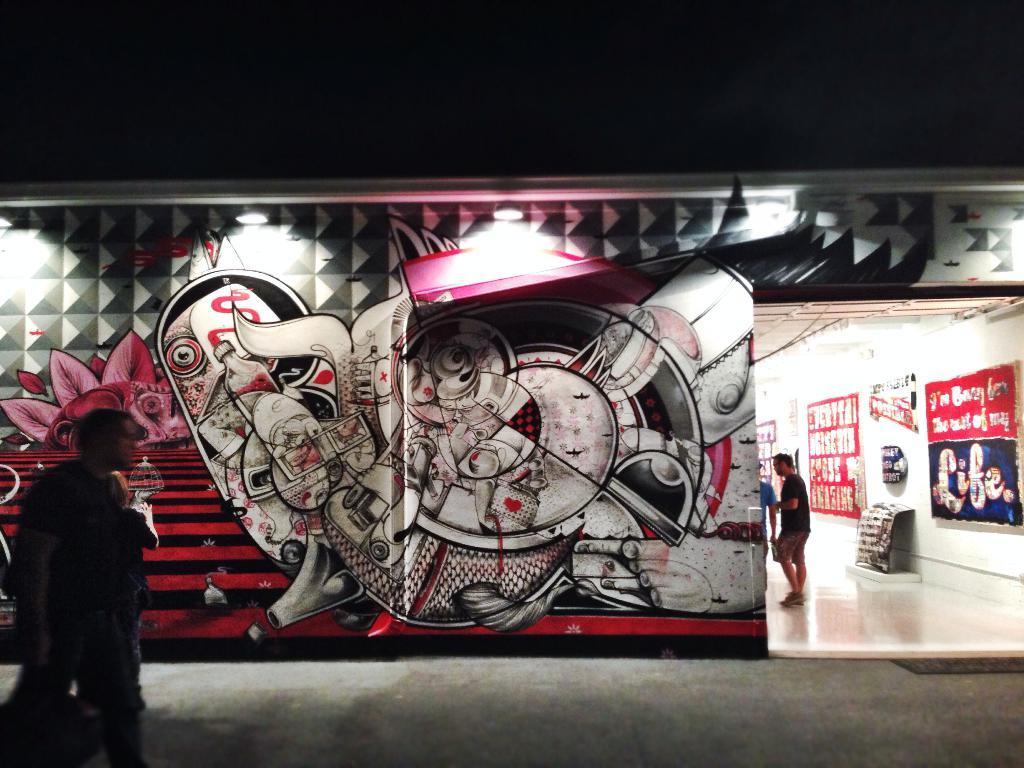Could you give a brief overview of what you see in this image? In the picture we can see a building wall with full of paintings on it and near it, we can see a person standing and beside the wall we can see a store with a white floor and a man standing and the wall is with posters. 